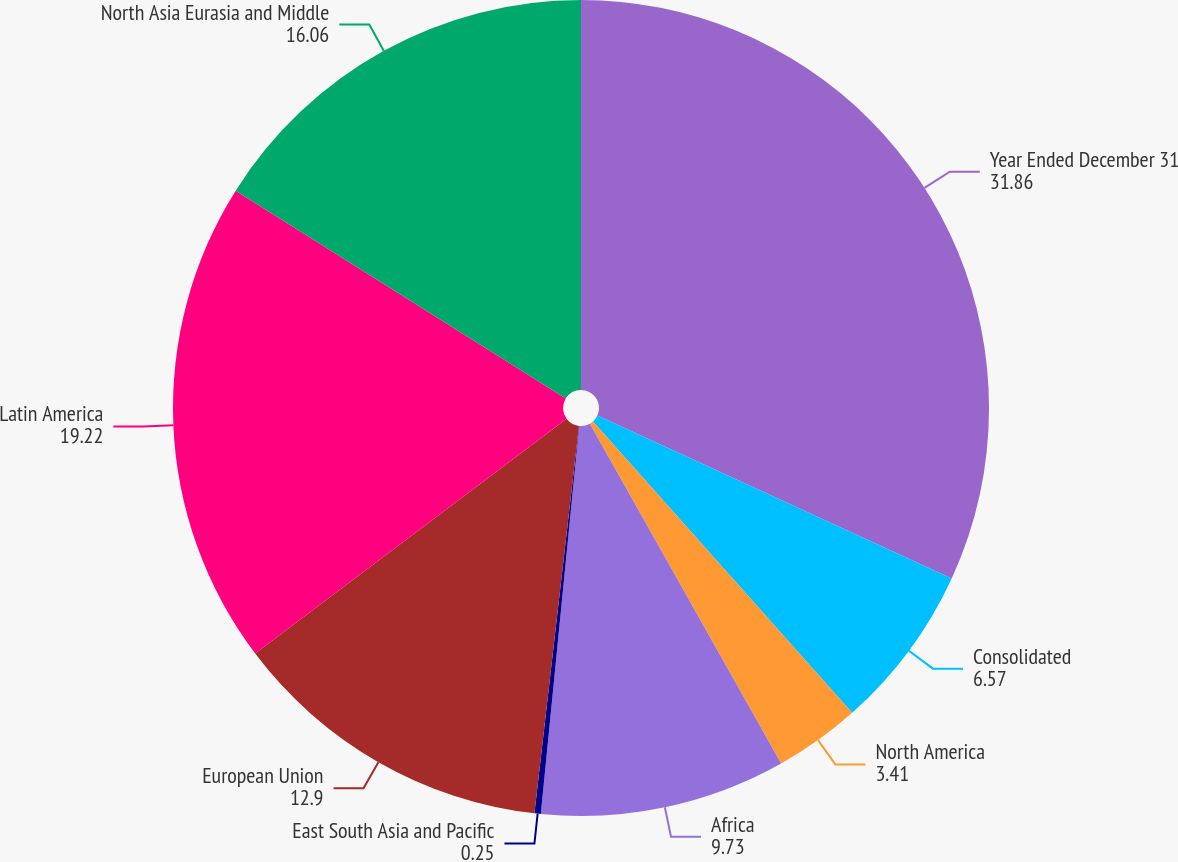Convert chart. <chart><loc_0><loc_0><loc_500><loc_500><pie_chart><fcel>Year Ended December 31<fcel>Consolidated<fcel>North America<fcel>Africa<fcel>East South Asia and Pacific<fcel>European Union<fcel>Latin America<fcel>North Asia Eurasia and Middle<nl><fcel>31.86%<fcel>6.57%<fcel>3.41%<fcel>9.73%<fcel>0.25%<fcel>12.9%<fcel>19.22%<fcel>16.06%<nl></chart> 